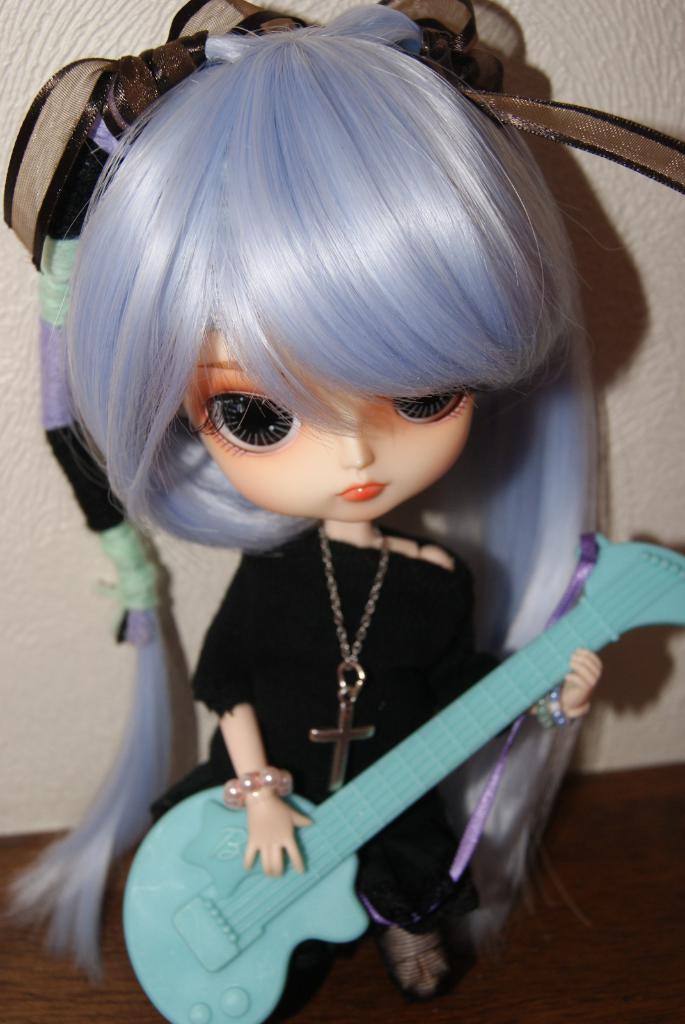How would you summarize this image in a sentence or two? Here I can see a Barbie toy which is dressed with a black color frock. There is a toy guitar in the hands. In the background there is a wall. 